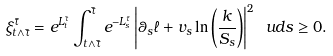Convert formula to latex. <formula><loc_0><loc_0><loc_500><loc_500>\xi _ { t \wedge { \bar { \tau } } } ^ { \bar { \tau } } = e ^ { L _ { t } ^ { \bar { \tau } } } \int _ { t \wedge { \bar { \tau } } } ^ { \bar { \tau } } e ^ { - L _ { s } ^ { \bar { \tau } } } \left | \theta _ { s } \ell + v _ { s } \ln \left ( \frac { k } { S _ { s } } \right ) \right | ^ { 2 } \ u d s \geq 0 .</formula> 